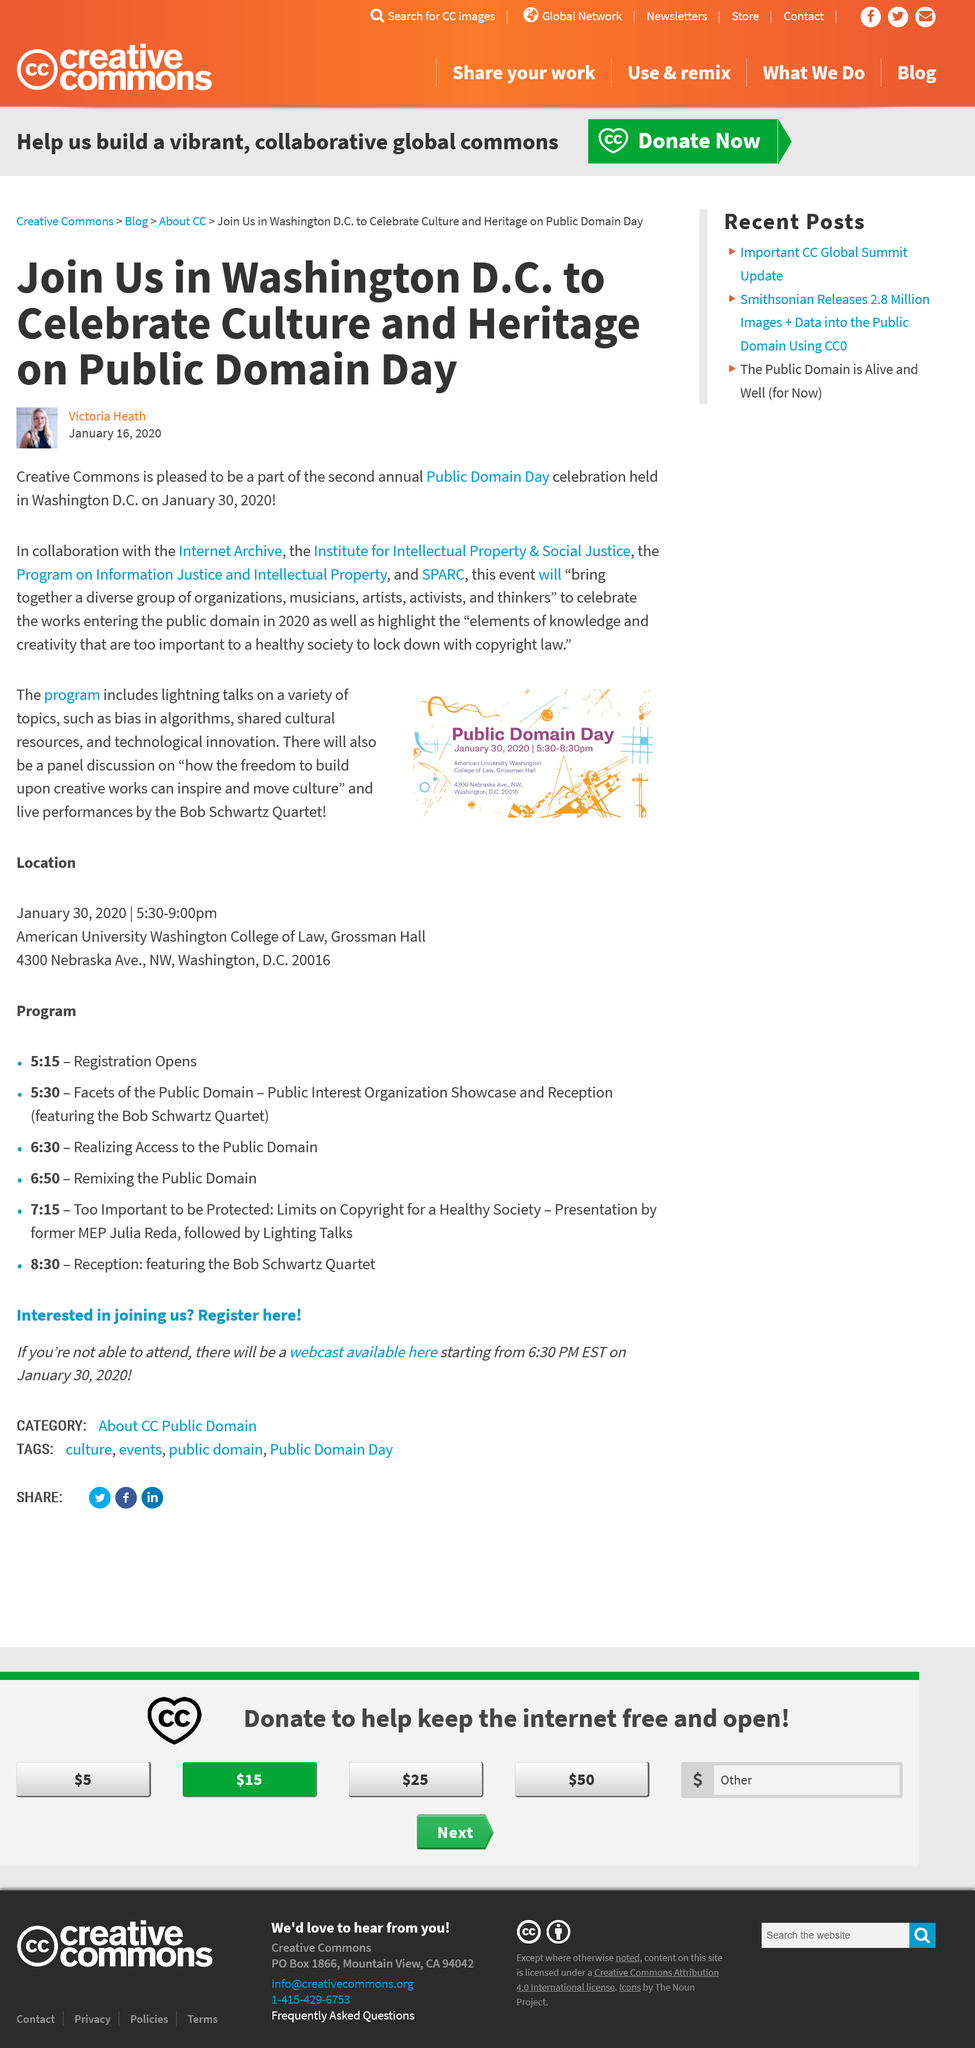Highlight a few significant elements in this photo. The celebration of Public Domain Day takes place in Washington D.C., where it is honored as a significant occasion. What is CC going to be a part of? It will be a part of the second annual Public Domain Day. Five groups are collaborating on the PDD. 